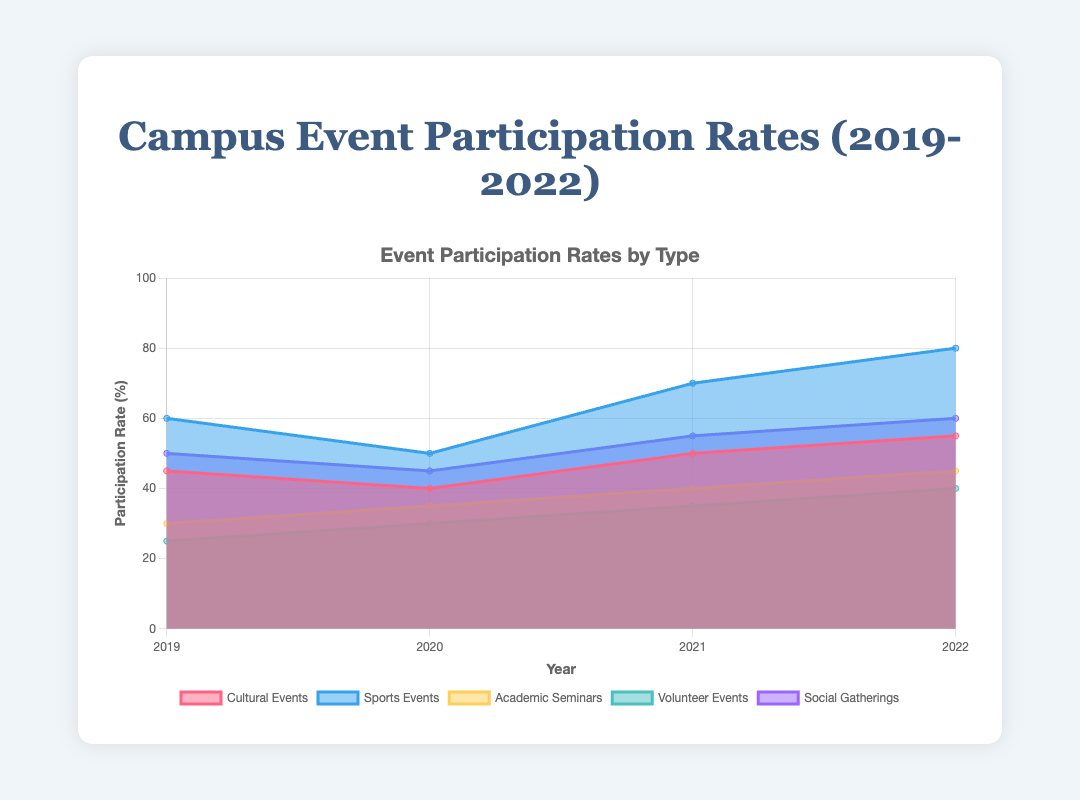What is the participation rate for Cultural Events in 2021? Look at the data point for Cultural Events at the year 2021 on the area chart.
Answer: 50 How did the participation rate for Social Gatherings change from 2019 to 2022? Observe the values for Social Gatherings in 2019 and 2022. Calculate the difference (60 - 50).
Answer: Increased by 10 Which event type had the highest participation rate in 2020? Compare the data points of all event types in the year 2020 and identify the highest value.
Answer: Sports Events What is the trend for Volunteer Events' participation rate from 2019 to 2022? Identify the data points for Volunteer Events across all years and analyze their progression over time.
Answer: Increasing trend Between which years did Academic Seminars see the largest increase? Compare the year-to-year changes for Academic Seminars and identify the largest increment. (2021-2022: 45-40 = 5, 2020-2021 = 5-30 = -5, 2019-2020: 35-30 = 5 )
Answer: 2020 to 2021 What is the sum of the participation rates for all events in 2020? Add up the participation rates of all event types for the year 2020. (40 + 50 + 35 + 30 + 45)
Answer: 200 Which event type had the most consistent participation rate from 2019 to 2022? Determine the event type with the least variation in participation rates across the years.
Answer: Academic Seminars What is the average participation rate for Cultural Events over the 4-year period? Calculate the sum of the participation rates for Cultural Events from 2019 to 2022 and divide by the number of years. ((45 + 40 + 50 + 55) / 4)
Answer: 47.5 How does the participation rate for Sports Events in 2022 compare to the rate for Volunteer Events in the same year? Compare the data points for Sports Events and Volunteer Events in the year 2022.
Answer: Sports Events had a higher rate During which year did Social Gatherings experience a decrease in participation rate? Identify the year where the participation rate for Social Gatherings is lower than the previous year. (45 in 2020 compared to 50 in 2019)
Answer: 2020 